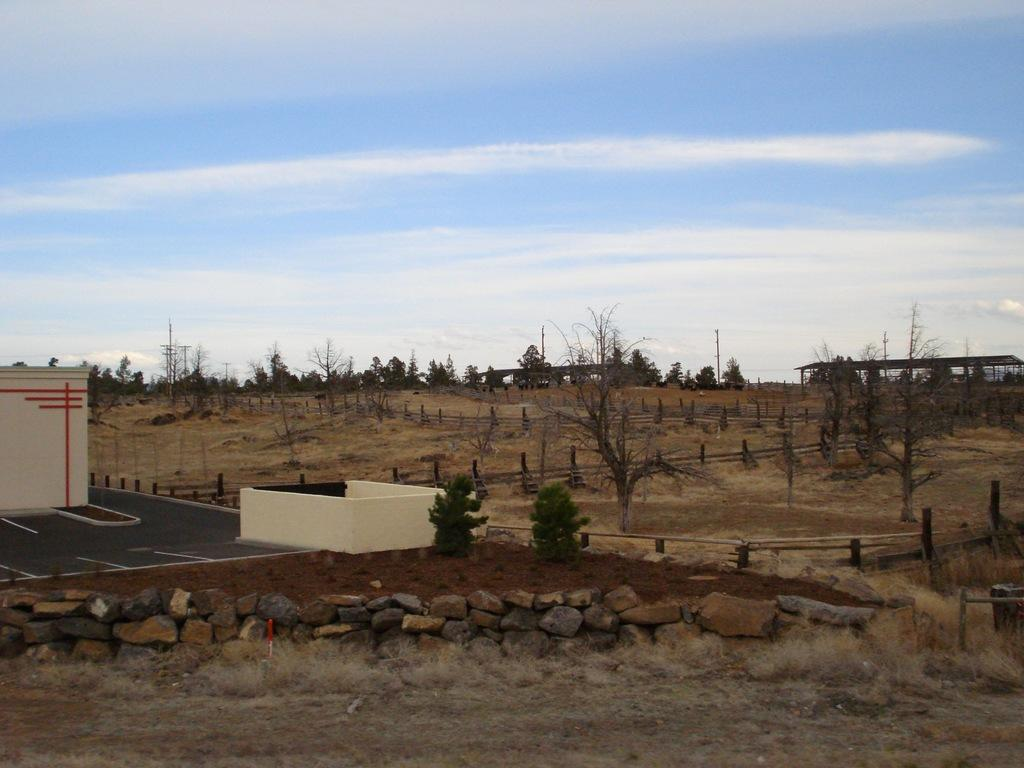What types of natural elements can be seen in the foreground of the image? There are stones, grass, and soil in the foreground of the image. What is located in the center of the image? There are trees, fencing, and buildings in the center of the image. What is visible in the top of the image? The sky is visible in the top of the image. Can you describe the sky's condition in the image? The sky is slightly cloudy in the image. What type of cord can be seen connecting the trees in the image? There is no cord connecting the trees in the image; the trees are separate entities. 